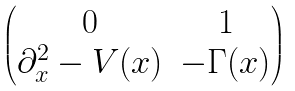Convert formula to latex. <formula><loc_0><loc_0><loc_500><loc_500>\begin{pmatrix} 0 & 1 \\ \partial _ { x } ^ { 2 } - V ( x ) & - \Gamma ( x ) \end{pmatrix}</formula> 